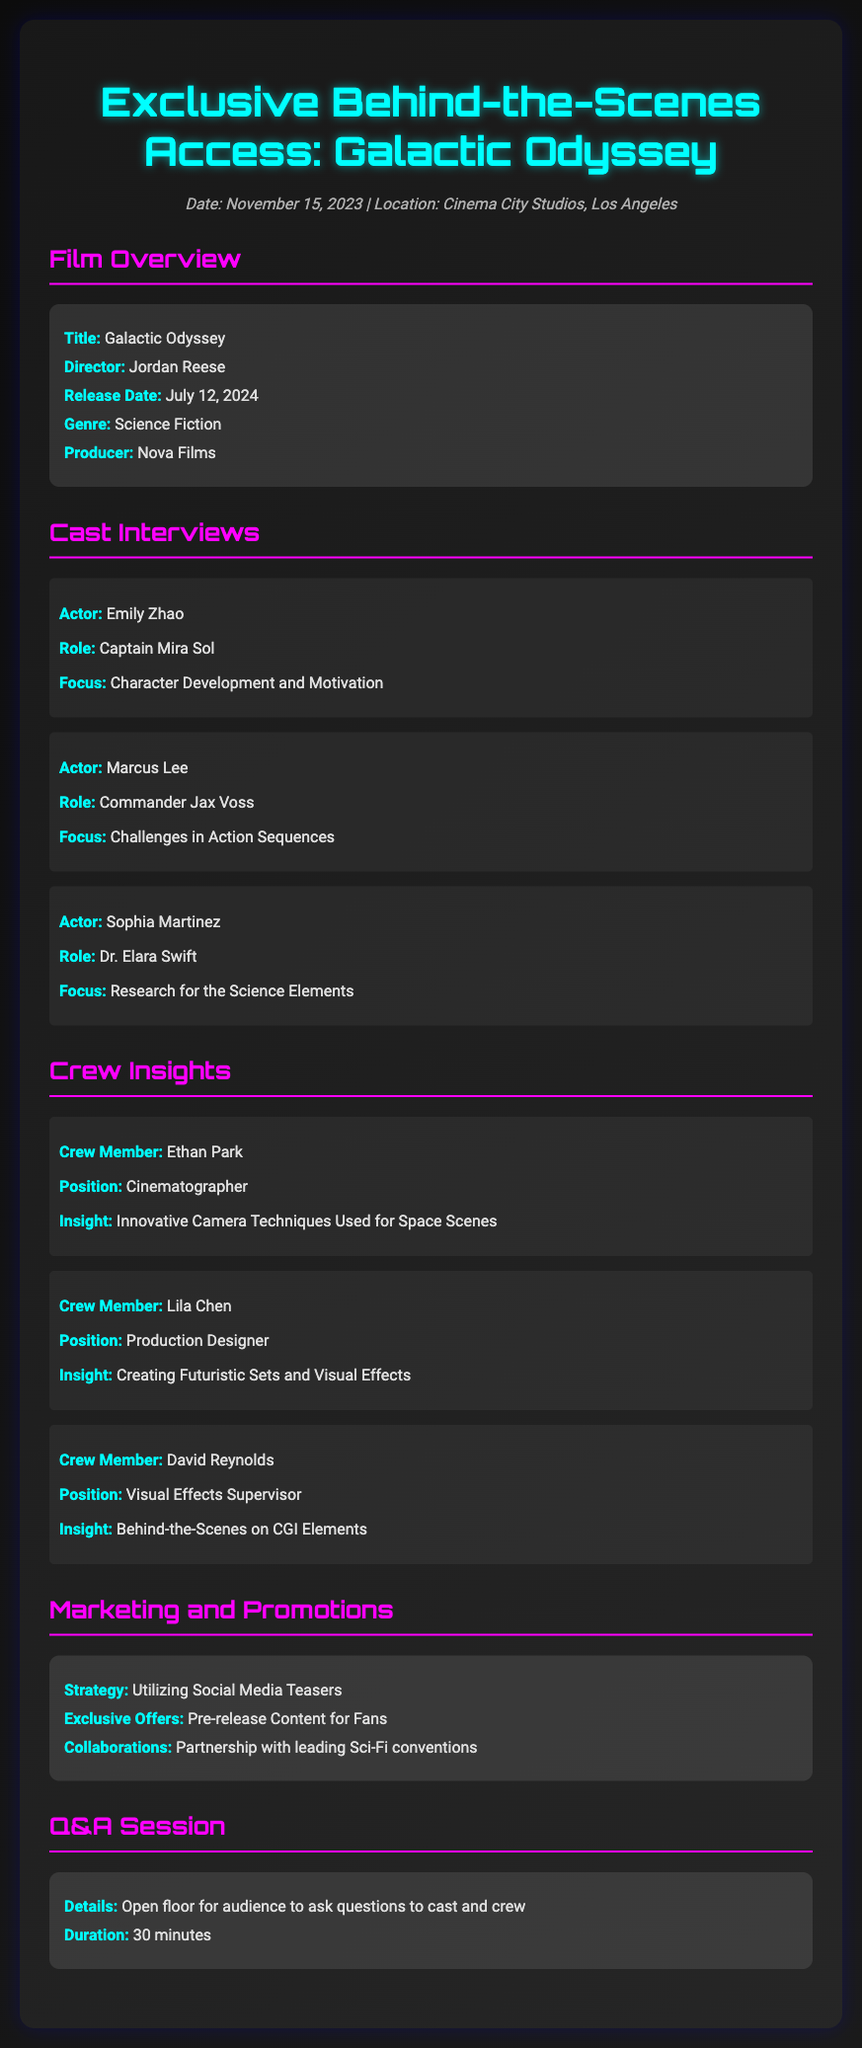What is the title of the film? The title of the film is explicitly stated in the document under "Film Overview."
Answer: Galactic Odyssey Who is the director of "Galactic Odyssey"? The director's name is mentioned in the "Film Overview" section.
Answer: Jordan Reese What is the release date of the film? The release date is specified in the "Film Overview" section of the document.
Answer: July 12, 2024 Which actor plays the role of Captain Mira Sol? The actor's name is provided in the "Cast Interviews" section under their respective role.
Answer: Emily Zhao What position does Ethan Park hold in the crew? Ethan Park's position can be found in the "Crew Insights" section.
Answer: Cinematographer What focuses on the character development in "Galactic Odyssey"? The focus area is specifically listed in the "Cast Interviews" section.
Answer: Character Development and Motivation What is the marketing strategy for the film? The strategy is described in the "Marketing and Promotions" section of the document.
Answer: Utilizing Social Media Teasers How long is the Q&A session scheduled for? The duration of the Q&A session is stated in the "Q&A Session" section.
Answer: 30 minutes Where is "Galactic Odyssey" being filmed? The location of the film's production is mentioned at the beginning of the document.
Answer: Cinema City Studios, Los Angeles 